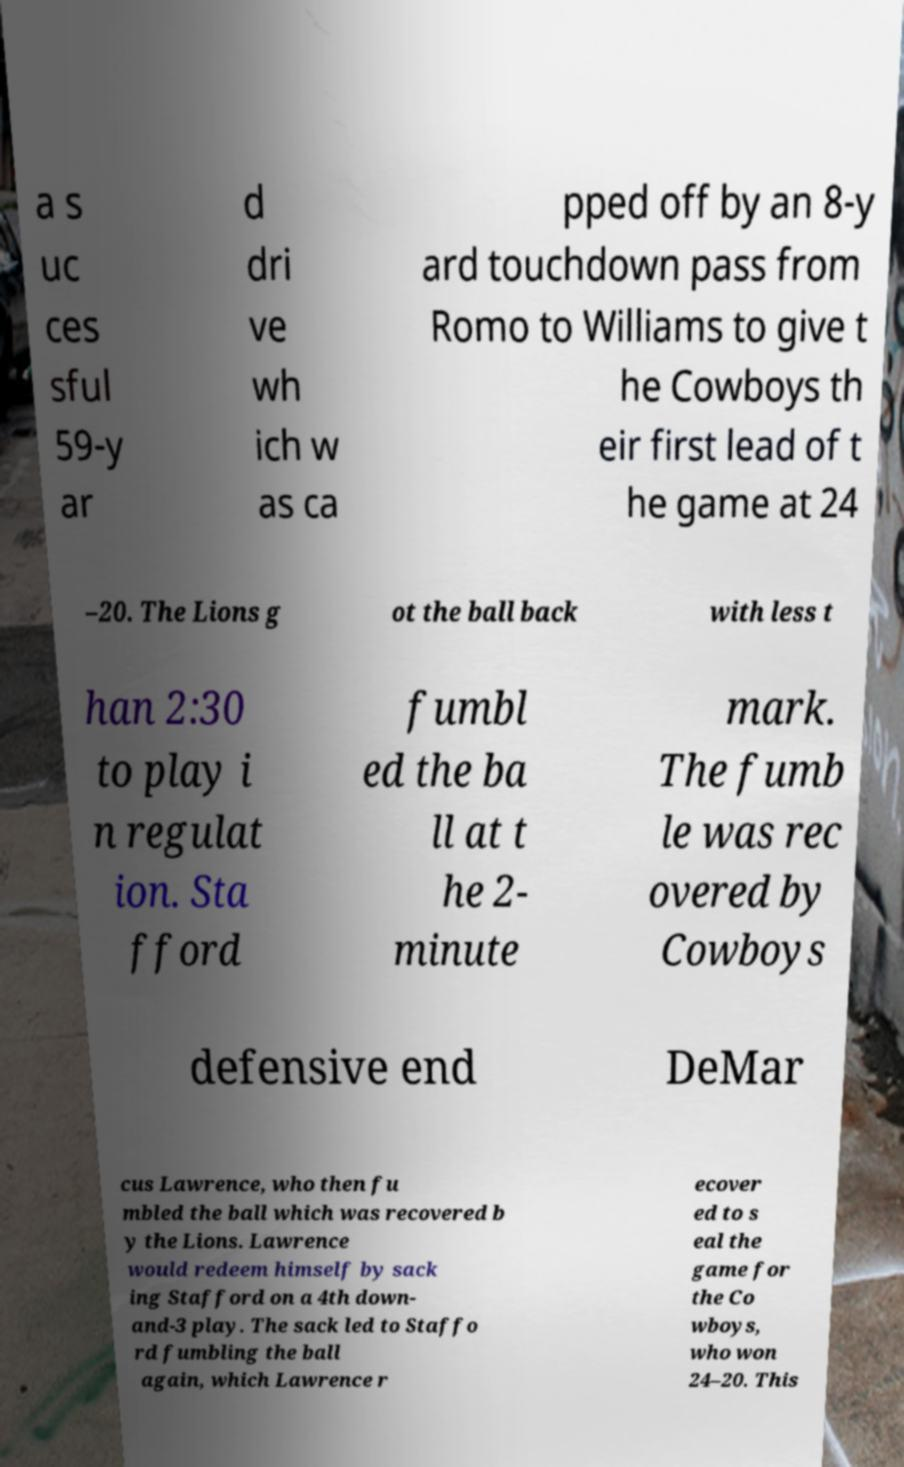I need the written content from this picture converted into text. Can you do that? a s uc ces sful 59-y ar d dri ve wh ich w as ca pped off by an 8-y ard touchdown pass from Romo to Williams to give t he Cowboys th eir first lead of t he game at 24 –20. The Lions g ot the ball back with less t han 2:30 to play i n regulat ion. Sta fford fumbl ed the ba ll at t he 2- minute mark. The fumb le was rec overed by Cowboys defensive end DeMar cus Lawrence, who then fu mbled the ball which was recovered b y the Lions. Lawrence would redeem himself by sack ing Stafford on a 4th down- and-3 play. The sack led to Staffo rd fumbling the ball again, which Lawrence r ecover ed to s eal the game for the Co wboys, who won 24–20. This 